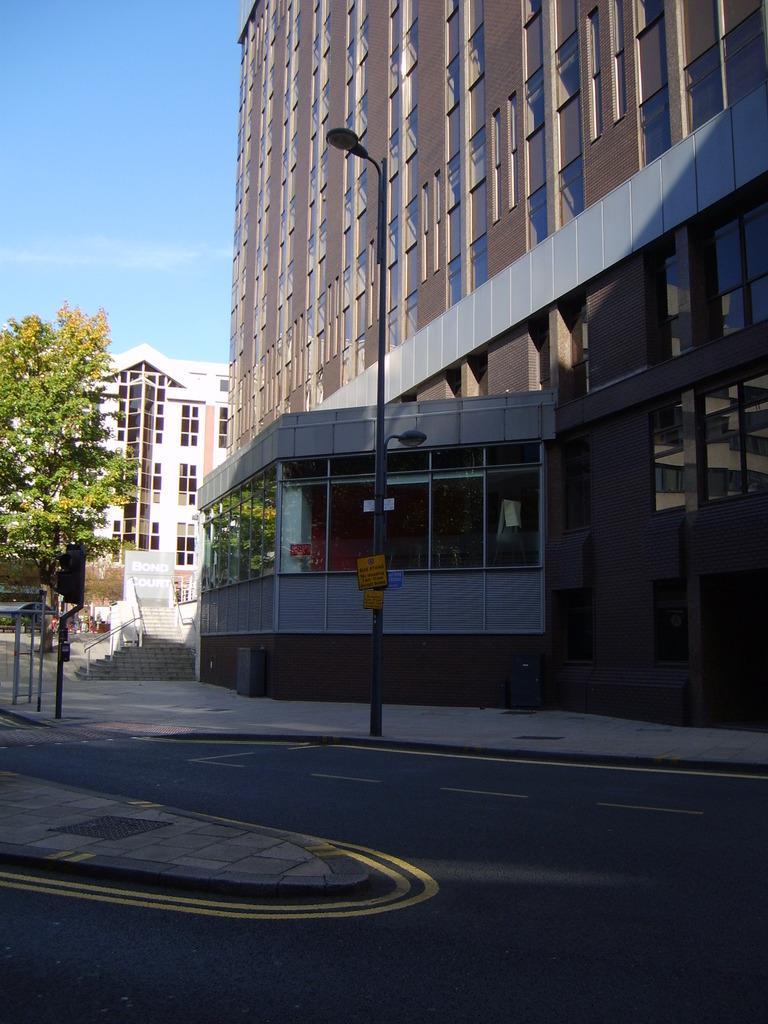In one or two sentences, can you explain what this image depicts? In the image we can see there is a road and there are street light poles on the ground. There are buildings and there is a clear sky. 